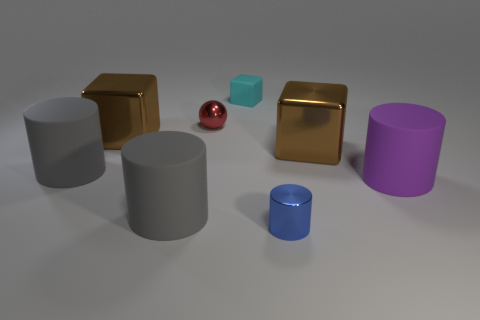Are there fewer red metallic spheres left of the cyan cube than rubber objects left of the shiny cylinder?
Provide a short and direct response. Yes. How many things are matte things right of the tiny matte thing or small things?
Provide a succinct answer. 4. There is a rubber cylinder in front of the purple thing; does it have the same size as the metallic cylinder?
Provide a short and direct response. No. Are there fewer cyan matte blocks on the right side of the cyan rubber cube than large rubber cylinders?
Your response must be concise. Yes. There is a cyan block that is the same size as the red thing; what material is it?
Provide a succinct answer. Rubber. How many small things are purple cylinders or rubber cylinders?
Give a very brief answer. 0. How many objects are large brown blocks on the right side of the tiny blue cylinder or brown cubes right of the small matte block?
Offer a terse response. 1. Is the number of cyan matte objects less than the number of tiny brown metallic cylinders?
Ensure brevity in your answer.  No. There is a blue metal thing that is the same size as the sphere; what is its shape?
Provide a succinct answer. Cylinder. What number of other objects are there of the same color as the metal ball?
Ensure brevity in your answer.  0. 